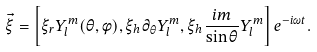Convert formula to latex. <formula><loc_0><loc_0><loc_500><loc_500>\vec { \xi } = \left [ \xi _ { r } Y _ { l } ^ { m } ( \theta , \phi ) , \xi _ { h } \partial _ { \theta } Y _ { l } ^ { m } , \xi _ { h } \frac { i m } { \sin \theta } Y _ { l } ^ { m } \right ] e ^ { - i \omega t } .</formula> 